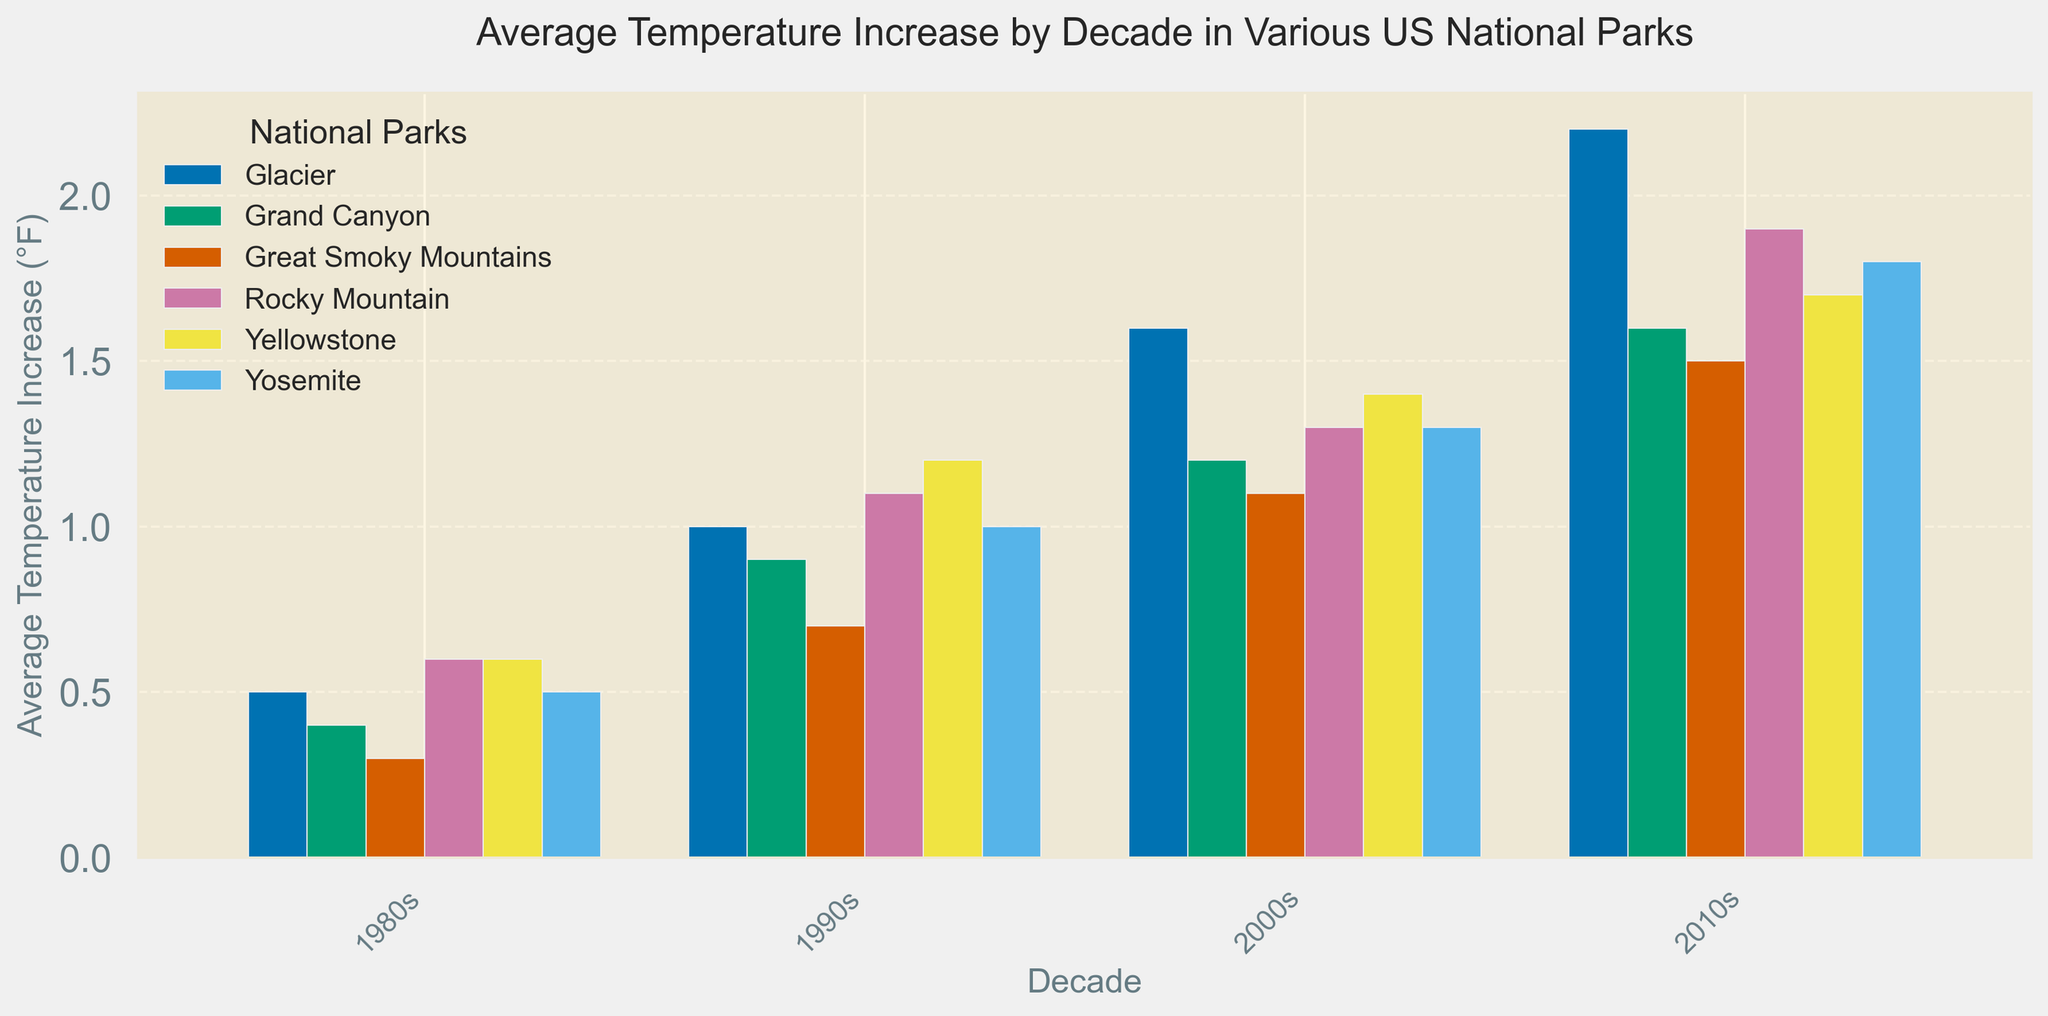Which national park experienced the highest average temperature increase in the 2010s? Look at the top of each bar for the 2010s and compare the values. Glacier shows the highest bar, indicating the highest temperature increase.
Answer: Glacier Which decade saw the greatest overall average temperature increase for the Grand Canyon? Compare the heights of the bars representing the Grand Canyon for each decade. The tallest bar is seen in the 2010s.
Answer: 2010s What's the difference in average temperature increase between Yellowstone and Yosemite in the 2000s? Find the bars for Yellowstone and Yosemite in the 2000s, then subtract Yosemite's value from Yellowstone's. 1.4°F (Yellowstone) - 1.3°F (Yosemite) = 0.1°F.
Answer: 0.1°F How did the average temperature increase for Rocky Mountain change from the 1990s to the 2010s? Find the bars for Rocky Mountain for both decades, then subtract the 1990s value from the 2010s value. 1.9°F (2010s) - 1.1°F (1990s) = 0.8°F.
Answer: 0.8°F Which park showed the least average temperature increase in the 1980s? Compare the heights of all the bars for the 1980s and identify the shortest one, which is Great Smoky Mountains.
Answer: Great Smoky Mountains What is the average temperature increase in the 2010s across all the parks? Sum the 2010s values for all parks and divide by the number of parks. (1.7 + 1.8 + 1.6 + 1.5 + 1.9 + 2.2) / 6 = 1.78°F.
Answer: 1.78°F In which decade did Glacier National Park experience the highest average temperature increase? Compare the heights of the bars for Glacier National Park for each decade. The highest bar is in the 2010s.
Answer: 2010s Which two parks had the same average temperature increase in any decade, if at all? Compare the bar heights. Yellowstone and Yosemite both had a 1.3°F increase in the 2000s.
Answer: Yellowstone and Yosemite in the 2000s How much did the average temperature increase in Yosemite between the 1980s and the 2010s? Subtract the average temperature increase in the 1980s from that in the 2010s for Yosemite. 1.8°F (2010s) - 0.5°F (1980s) = 1.3°F.
Answer: 1.3°F By how much did the average temperature increase in Yellowstone from the 1980s to the 1990s? Subtract the 1980s increase from the 1990s increase for Yellowstone. 1.2°F (1990s) - 0.6°F (1980s) = 0.6°F.
Answer: 0.6°F 